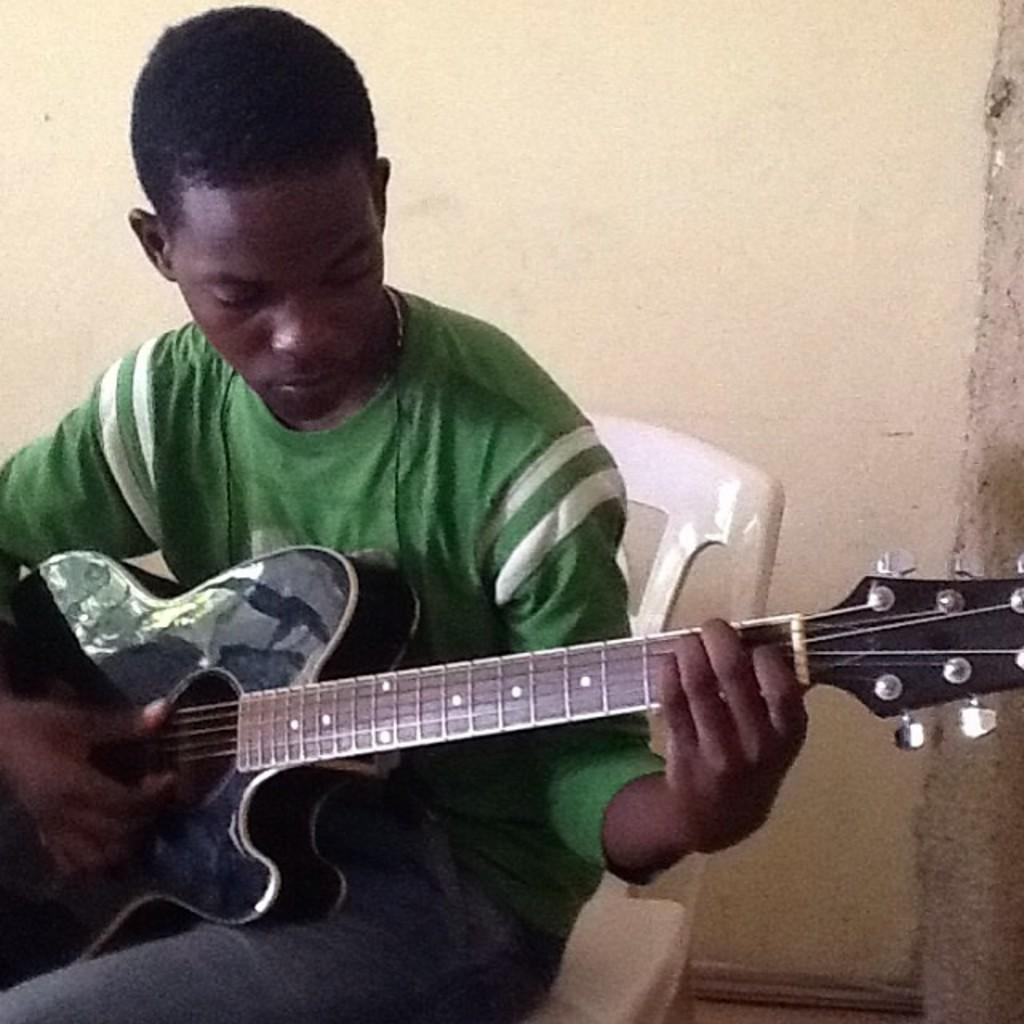Who is the person in the image? There is a man in the image. What is the man doing in the image? The man is sitting on a chair and playing the guitar. What object is the man holding in the image? The man is holding a guitar. What can be seen in the background of the image? There is a wall in the background of the image. What is the color of the wall in the image? The wall is cream-colored. What type of swing can be seen in the image? There is no swing present in the image. What line is the man following while playing the guitar in the image? The man is not following any line while playing the guitar in the image. 